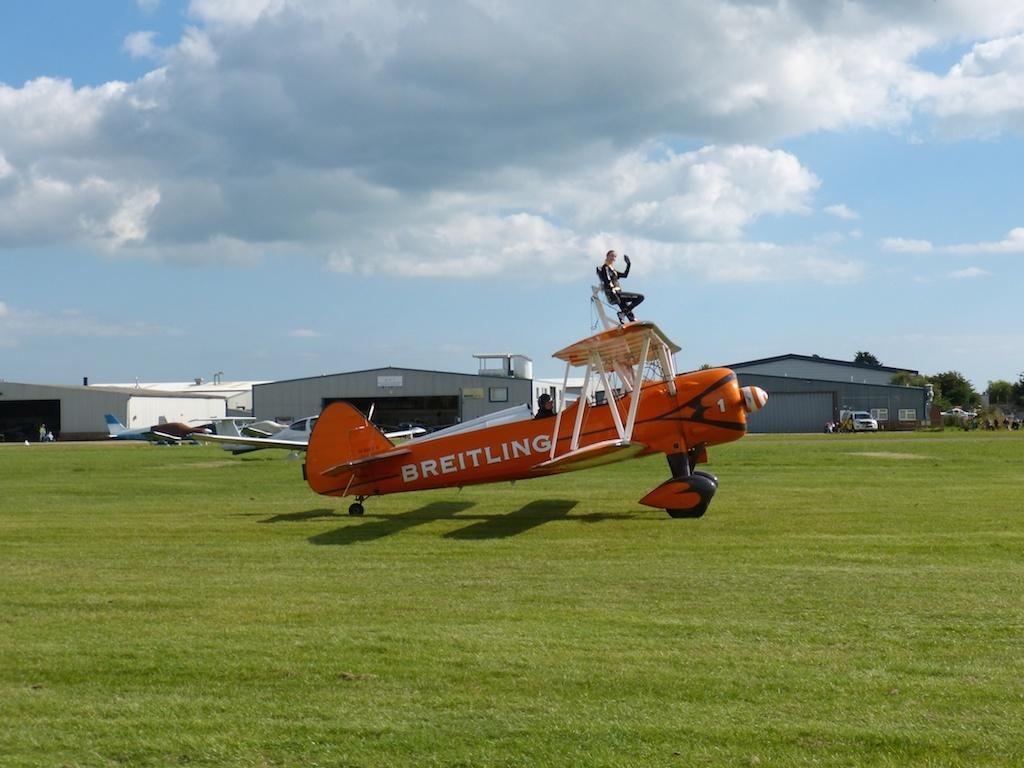<image>
Present a compact description of the photo's key features. A Breitling stuntplane sits in front of a hangar on an airfield. 